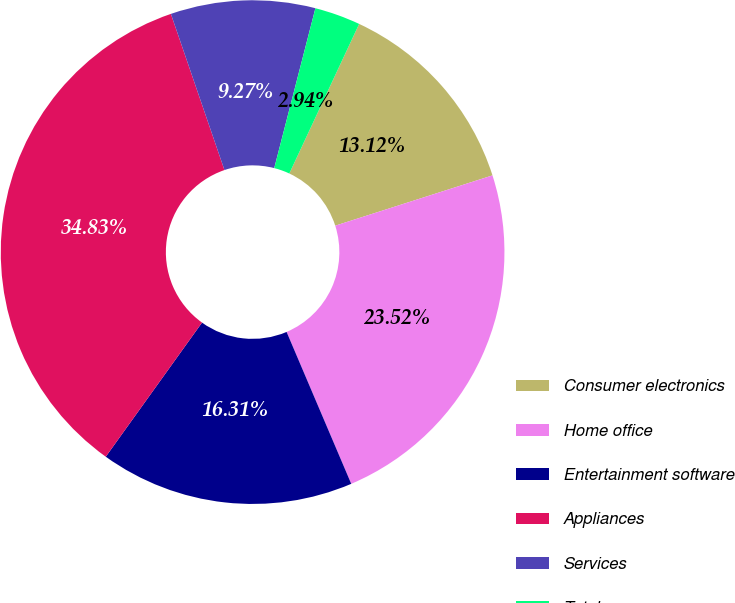Convert chart to OTSL. <chart><loc_0><loc_0><loc_500><loc_500><pie_chart><fcel>Consumer electronics<fcel>Home office<fcel>Entertainment software<fcel>Appliances<fcel>Services<fcel>Total<nl><fcel>13.12%<fcel>23.52%<fcel>16.31%<fcel>34.83%<fcel>9.27%<fcel>2.94%<nl></chart> 